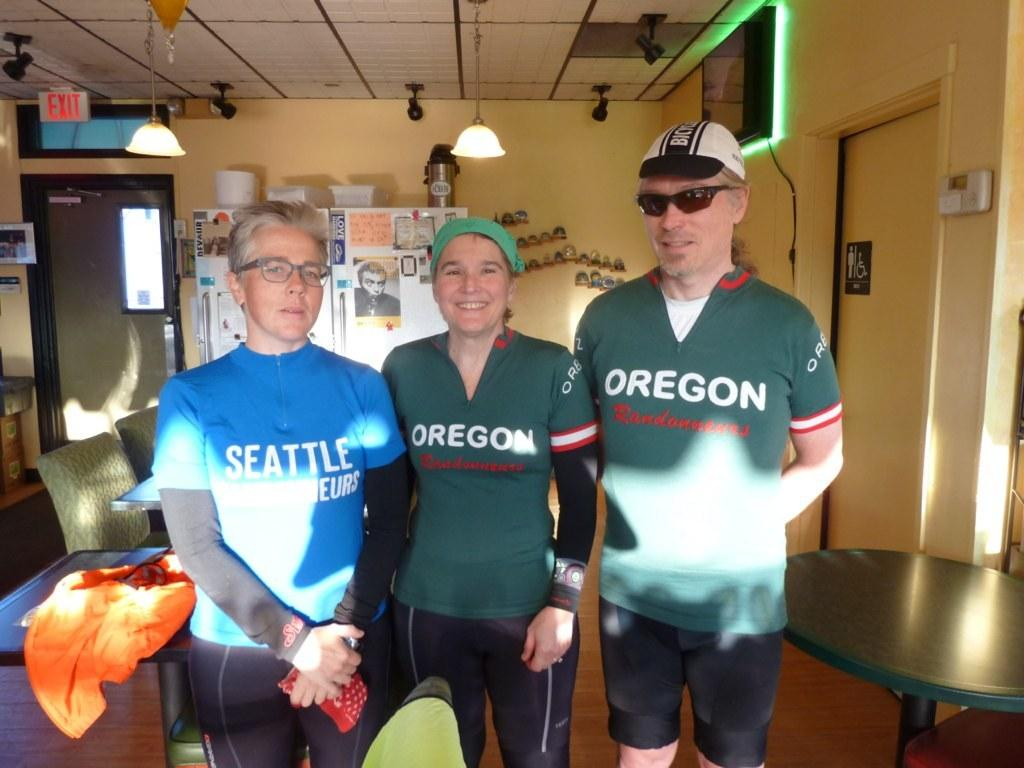Provide a one-sentence caption for the provided image. Bike riders with Seattle and Oregon shirts stand in a yellow room. 